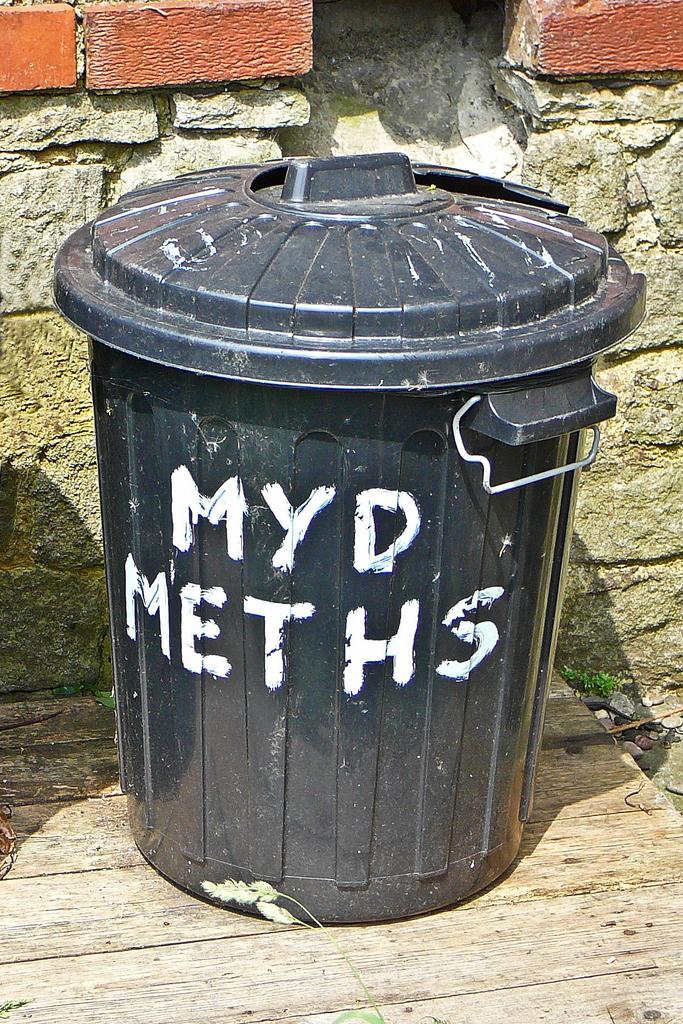Provide a one-sentence caption for the provided image. A black trashcan sits on wood boards ant it says MYD Meths on it. 